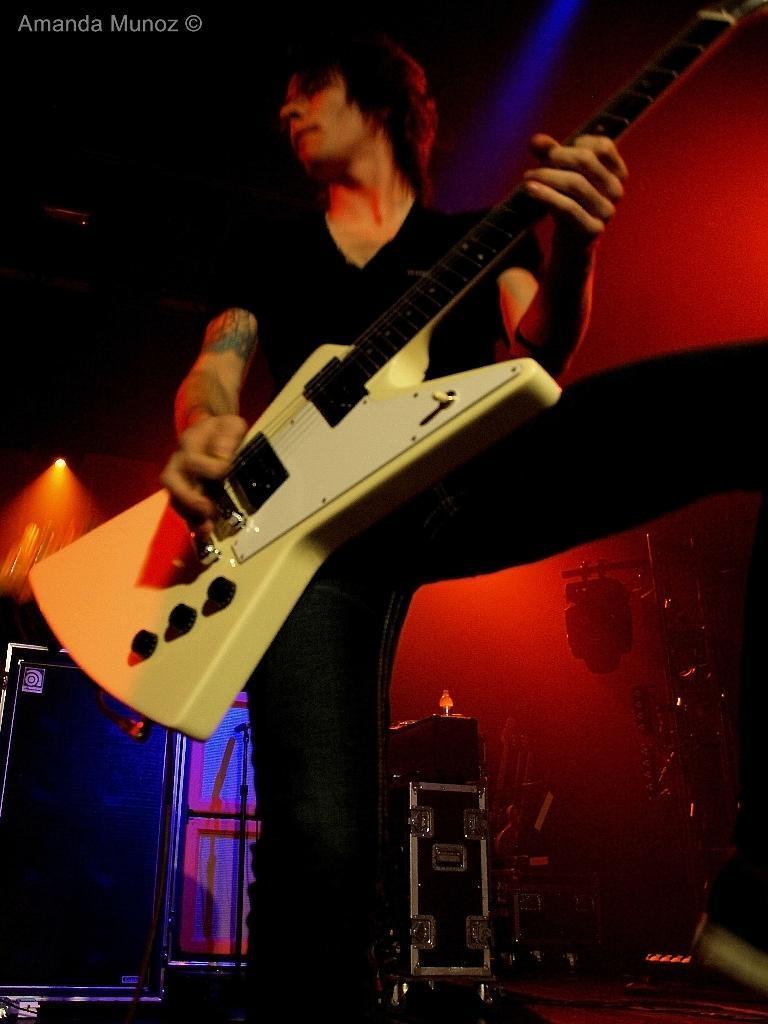In one or two sentences, can you explain what this image depicts? In the image we can see a person standing and he is holding a guitar in his hand. These are the musical instruments. This is a watermark. There is a red light emitting. 